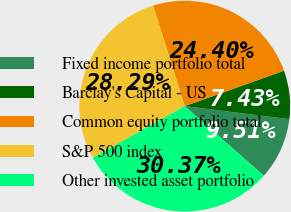Convert chart. <chart><loc_0><loc_0><loc_500><loc_500><pie_chart><fcel>Fixed income portfolio total<fcel>Barclay's Capital - US<fcel>Common equity portfolio total<fcel>S&P 500 index<fcel>Other invested asset portfolio<nl><fcel>9.51%<fcel>7.43%<fcel>24.4%<fcel>28.29%<fcel>30.37%<nl></chart> 